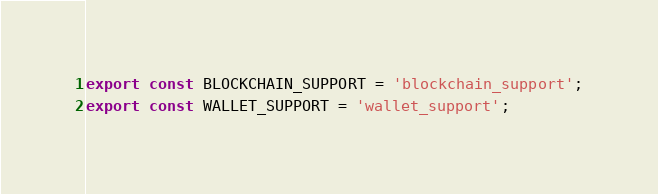<code> <loc_0><loc_0><loc_500><loc_500><_JavaScript_>export const BLOCKCHAIN_SUPPORT = 'blockchain_support';
export const WALLET_SUPPORT = 'wallet_support';</code> 